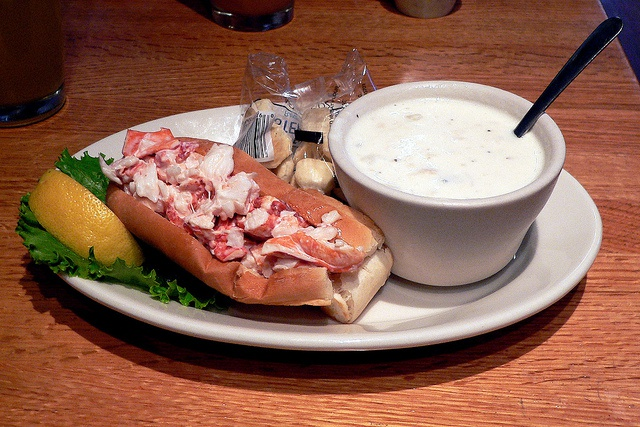Describe the objects in this image and their specific colors. I can see dining table in black, maroon, and brown tones, bowl in black, white, gray, and darkgray tones, cup in black, white, gray, and darkgray tones, hot dog in black, lightpink, brown, and salmon tones, and sandwich in black, lightpink, brown, and salmon tones in this image. 